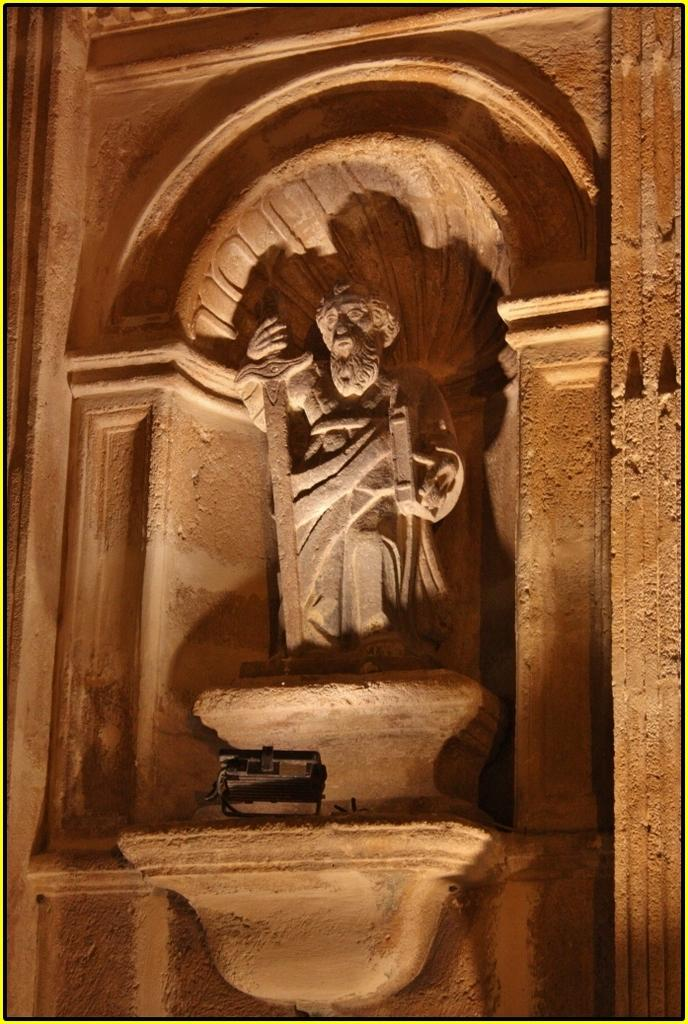What is the main subject of the image? There is a statue of a person in the image. What is the person holding in their hand? The person is holding a sword in their hand. Can you describe the black object in the image? There is a black object in the image, but its specific details are not clear from the provided facts. What can be seen on the wall in the image? There are things visible on the wall in the image, but their specific details are not clear from the provided facts. What type of quilt is being used to cover the person in the image? There is no quilt present in the image; it features a statue of a person holding a sword. What is the reason for the person's journey in the image? There is no journey depicted in the image; it features a statue of a person holding a sword. 